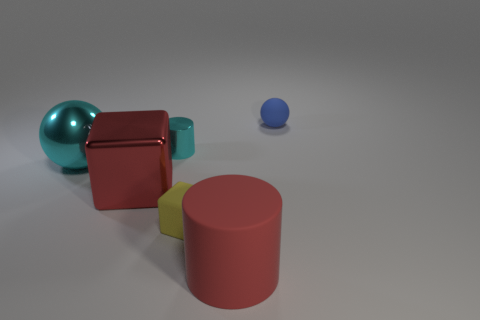Add 3 small cyan things. How many objects exist? 9 Subtract all spheres. How many objects are left? 4 Subtract all big cylinders. Subtract all red metal objects. How many objects are left? 4 Add 5 tiny cylinders. How many tiny cylinders are left? 6 Add 1 large red cylinders. How many large red cylinders exist? 2 Subtract 0 gray cubes. How many objects are left? 6 